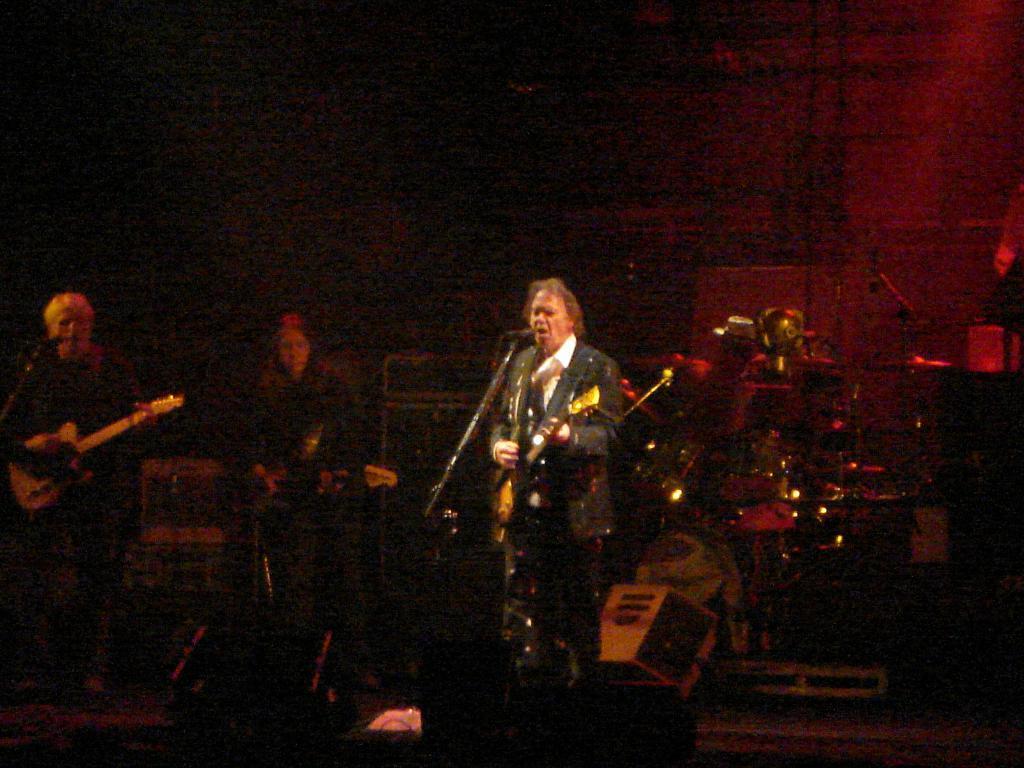Could you give a brief overview of what you see in this image? In the image we can see there are people who are standing and they are holding a guitar in their hand and at the back there are drums and speaker. 